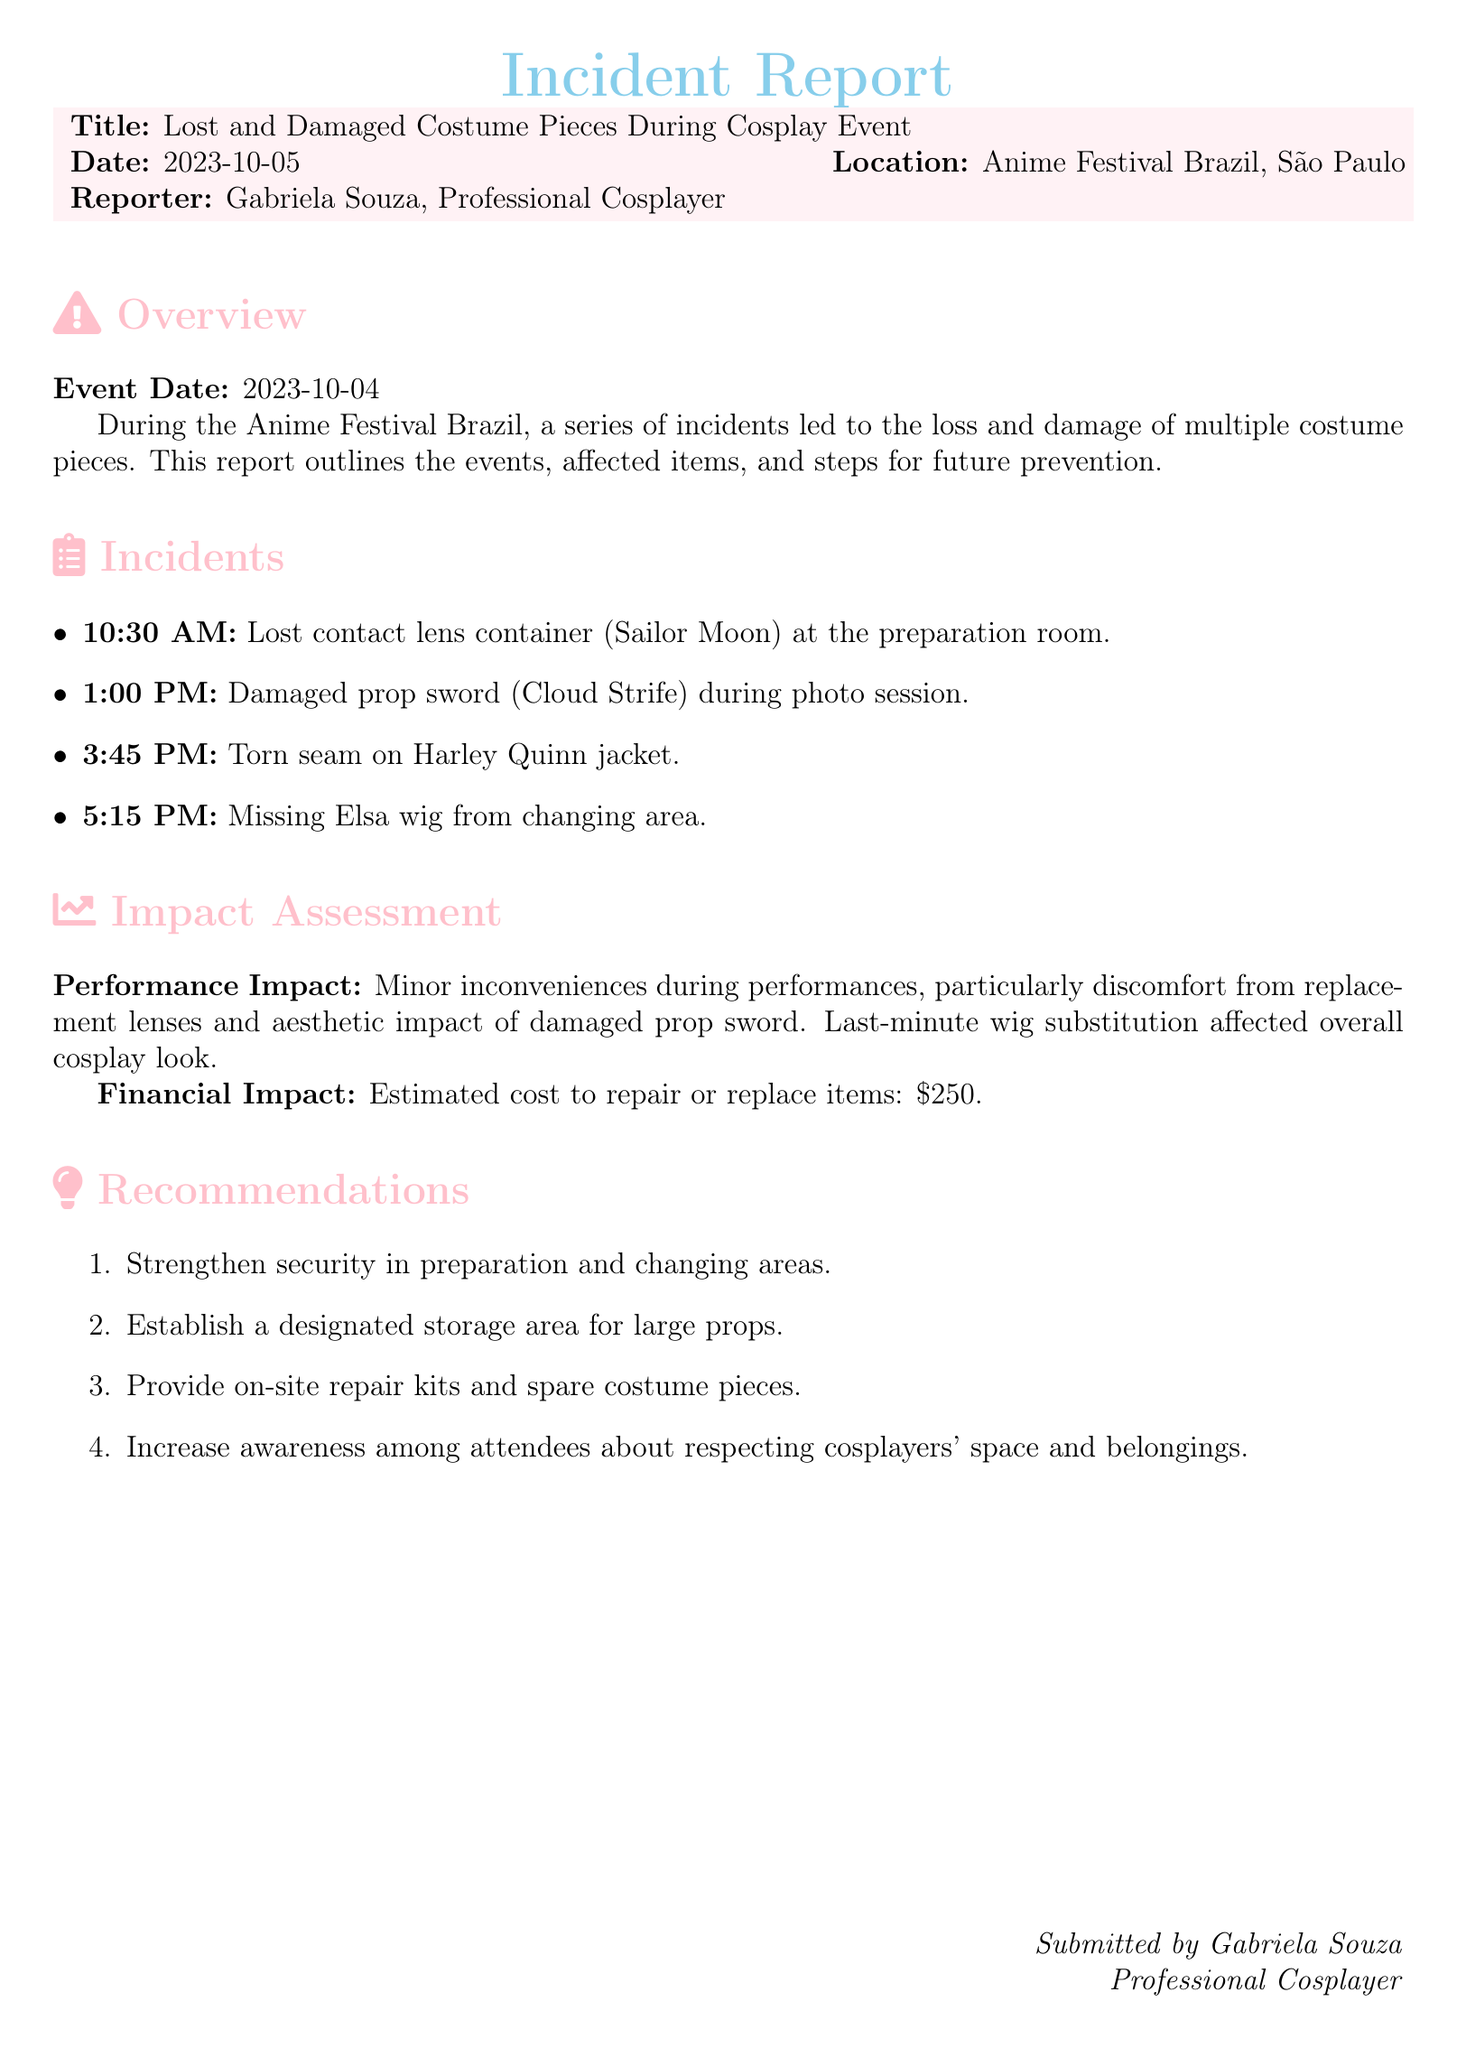What is the title of the report? The title of the report is indicated at the beginning of the document.
Answer: Lost and Damaged Costume Pieces During a Cosplay Event Who reported the incident? The report lists Gabriela Souza as the person who created the document under the reporter section.
Answer: Gabriela Souza What time did the torn seam incident occur? The document provides a specific time for each incident; the torn seam incident is listed at 3:45 PM.
Answer: 3:45 PM What is the estimated cost to repair or replace the items? The report includes an assessment of the financial impact with a specific monetary value.
Answer: $250 What costume was associated with the lost contact lens container? The incident report mentions specific costumes linked to each incident; the contact lens container was for Sailor Moon.
Answer: Sailor Moon Which item was missing from the changing area? The document lists missing items, specifically mentioning what was absent from the designated area.
Answer: Elsa wig What recommendations are made regarding security? The recommendations section suggests improving safety, which is crucial for future events.
Answer: Strengthen security in preparation and changing areas How many incidents are reported in total? Counting the listed incidents in the document provides the total number of events that occurred.
Answer: Four incidents What was the performance impact described in the report? The report discusses how the incidents affected performance, highlighting the discomfort and aesthetic issues.
Answer: Minor inconveniences during performances 